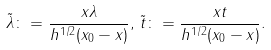Convert formula to latex. <formula><loc_0><loc_0><loc_500><loc_500>\tilde { \lambda } \colon = \frac { x \lambda } { h ^ { 1 / 2 } ( x _ { 0 } - x ) } , \, \tilde { t } \colon = \frac { x t } { h ^ { 1 / 2 } ( x _ { 0 } - x ) } .</formula> 